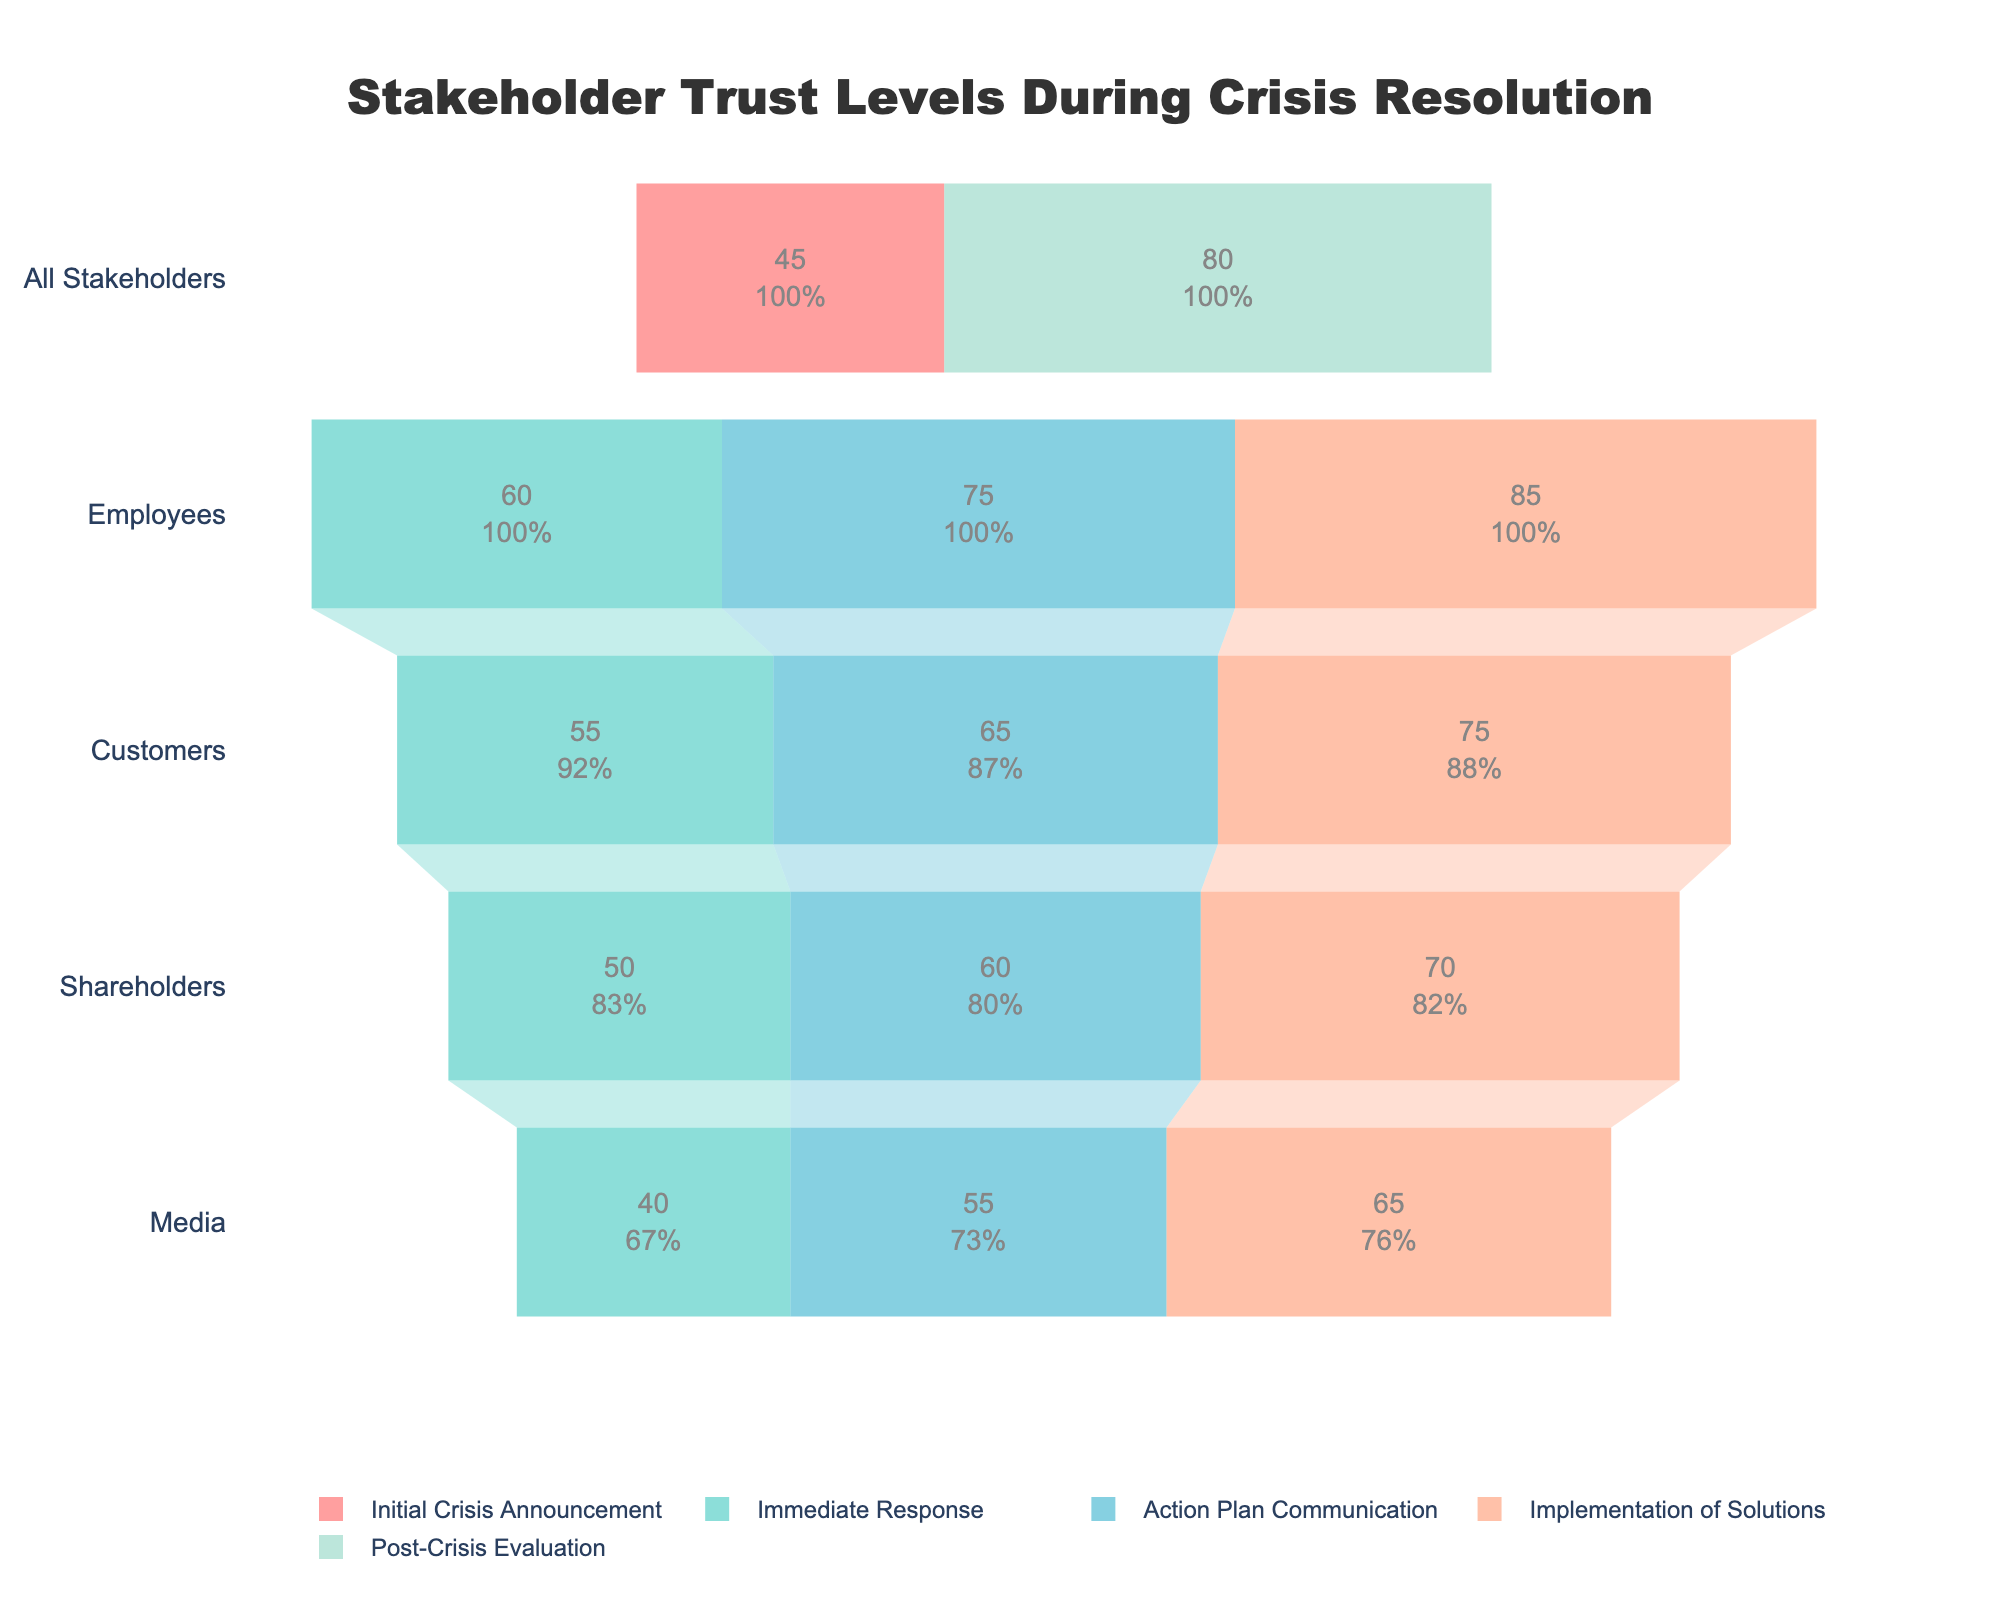What stage has the highest overall trust level? Look for the stage with the funnel segment at the highest level. The "Post-Crisis Evaluation" stage has an overall trust level of 80, which is the highest.
Answer: Post-Crisis Evaluation Which stakeholder group had the lowest trust level during the Immediate Response stage? Look for the lowest trust level among the different stakeholder groups during the Immediate Response stage. The Media group had the lowest trust, with a level of 40.
Answer: Media How much did the trust level of Employees change from the Initial Crisis Announcement to the Post-Crisis Evaluation? Subtract the trust level at the Initial Crisis Announcement from the trust level at the Post-Crisis Evaluation for Employees. Since Employees aren't a separate group in the Initial Crisis Announcement, we assume equal division among groups. The initial is 45 and the post-crisis for all stakeholders is 80. Thus, it's a comparison against all stakeholders.
Answer: +35 Which stakeholder group showed the most significant increase in trust level from the Immediate Response stage to the Implementation of Solutions stage? Calculate the difference in trust levels between these two stages for each group. Employees showed the largest increase, from 60 to 85, thus an increase of 25.
Answer: Employees What is the average trust level for all stakeholders during the Action Plan Communication stage? Calculate the average of the trust levels for all stakeholder groups during this stage. The values are 75, 65, 60, and 55. Thus, (75 + 65 + 60 + 55) / 4 = 63.75.
Answer: 63.75 Based on the chart, which stakeholder group appears to be the most trusting throughout the crisis resolution process? Compare the trust levels of different stakeholder groups across various stages to determine the most consistent or highest values. Employees have higher trust levels consistently across stages.
Answer: Employees By how much does the trust level of Customers change from the Immediate Response stage to the Action Plan Communication stage? Subtract the trust levels: 65 (Action Plan) - 55 (Immediate Response) = 10.
Answer: +10 At which stage did the stakeholders experience the most significant improvement in trust levels? Look for stages with the most considerable positive jump in trust levels. The jump from Immediate Response to Action Plan Communication shows a significant increase across multiple groups.
Answer: Immediate Response to Action Plan Communication 